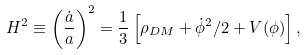Convert formula to latex. <formula><loc_0><loc_0><loc_500><loc_500>H ^ { 2 } \equiv \left ( \frac { \dot { a } } { a } \right ) ^ { 2 } = \frac { 1 } { 3 } \left [ \rho _ { D M } + \dot { \phi } ^ { 2 } / 2 + V ( \phi ) \right ] ,</formula> 